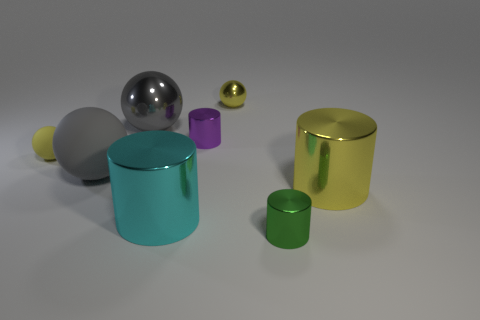Add 1 small metallic spheres. How many objects exist? 9 Subtract all large yellow metal cylinders. How many cylinders are left? 3 Subtract 1 cylinders. How many cylinders are left? 3 Add 4 yellow metal spheres. How many yellow metal spheres exist? 5 Subtract all yellow spheres. How many spheres are left? 2 Subtract 1 purple cylinders. How many objects are left? 7 Subtract all blue spheres. Subtract all purple cylinders. How many spheres are left? 4 Subtract all gray balls. How many cyan cylinders are left? 1 Subtract all big gray metal spheres. Subtract all tiny yellow matte balls. How many objects are left? 6 Add 4 purple metallic objects. How many purple metallic objects are left? 5 